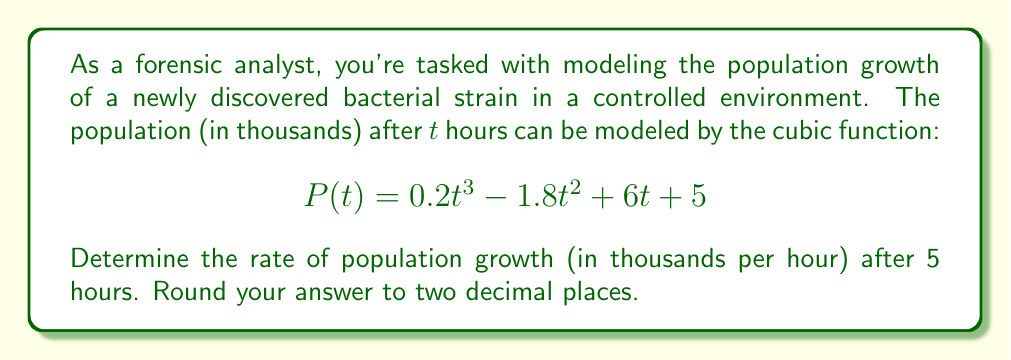Give your solution to this math problem. To solve this problem, we need to follow these steps:

1) The rate of population growth at any given time is represented by the derivative of the population function. So, we need to find P'(t).

2) To find P'(t), we differentiate P(t) with respect to t:
   $$P'(t) = \frac{d}{dt}(0.2t^3 - 1.8t^2 + 6t + 5)$$

3) Using the power rule of differentiation:
   $$P'(t) = 0.6t^2 - 3.6t + 6$$

4) Now that we have the rate function, we need to evaluate it at t = 5:
   $$P'(5) = 0.6(5)^2 - 3.6(5) + 6$$

5) Let's calculate this step by step:
   $$P'(5) = 0.6(25) - 3.6(5) + 6$$
   $$P'(5) = 15 - 18 + 6$$
   $$P'(5) = 3$$

6) The question asks for the answer rounded to two decimal places, so our final answer is 3.00.

This approach allows us to derive a data-driven conclusion about the bacterial population's growth rate, aligning with the persona's preference for empirical analysis.
Answer: 3.00 thousand per hour 